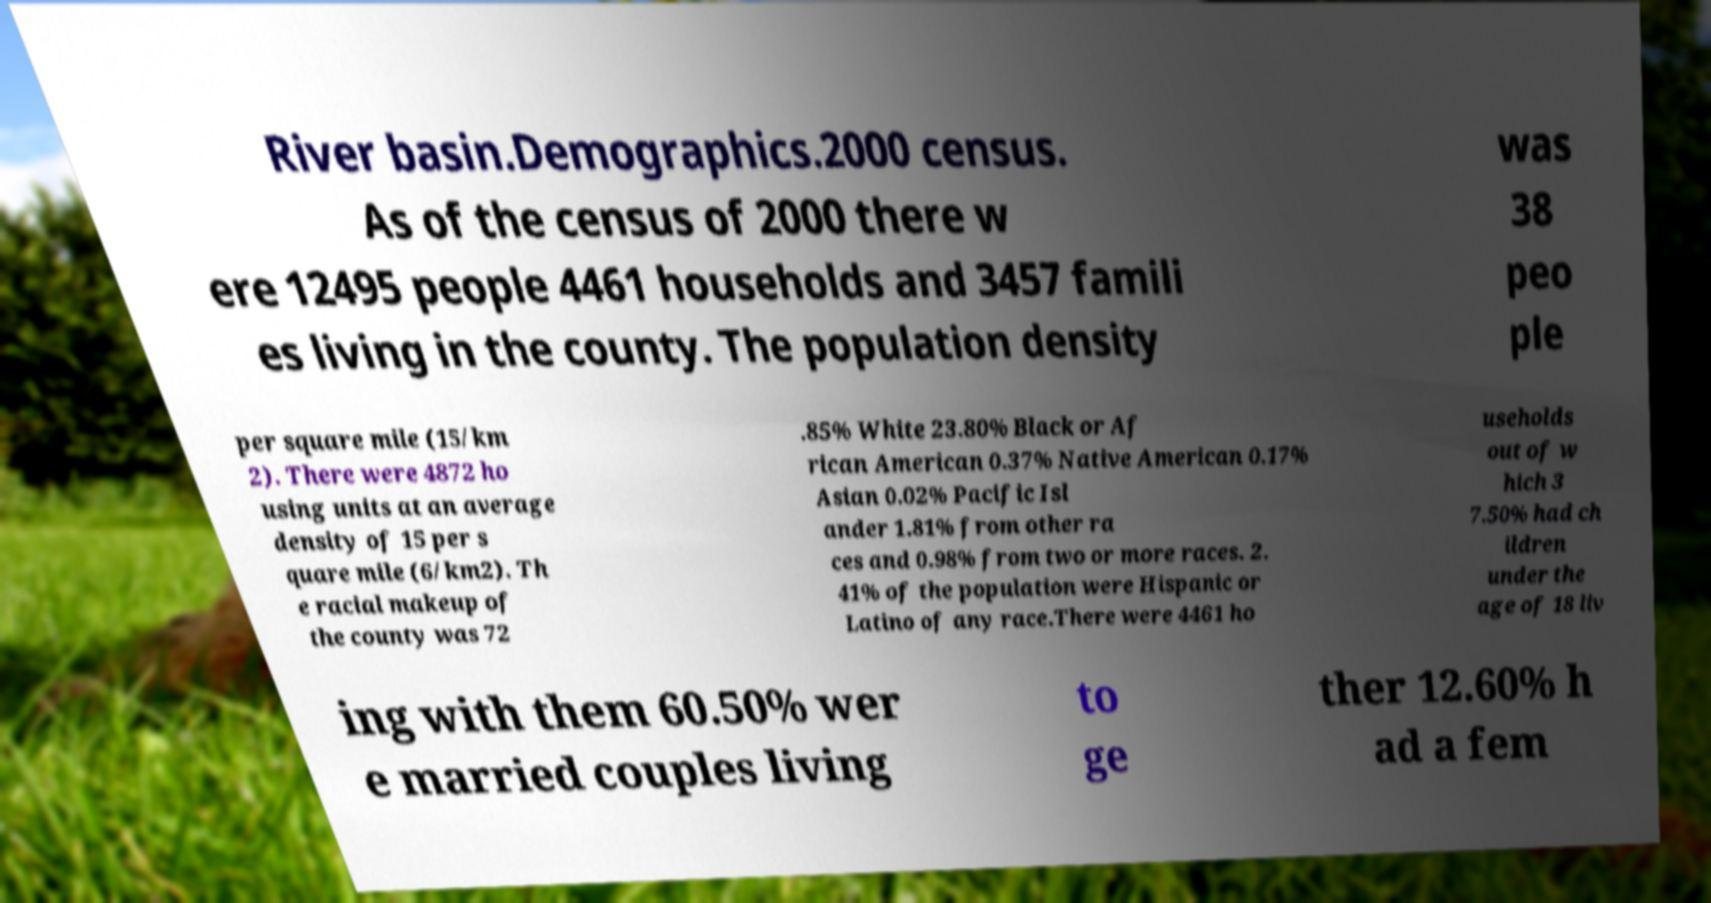Could you extract and type out the text from this image? River basin.Demographics.2000 census. As of the census of 2000 there w ere 12495 people 4461 households and 3457 famili es living in the county. The population density was 38 peo ple per square mile (15/km 2). There were 4872 ho using units at an average density of 15 per s quare mile (6/km2). Th e racial makeup of the county was 72 .85% White 23.80% Black or Af rican American 0.37% Native American 0.17% Asian 0.02% Pacific Isl ander 1.81% from other ra ces and 0.98% from two or more races. 2. 41% of the population were Hispanic or Latino of any race.There were 4461 ho useholds out of w hich 3 7.50% had ch ildren under the age of 18 liv ing with them 60.50% wer e married couples living to ge ther 12.60% h ad a fem 